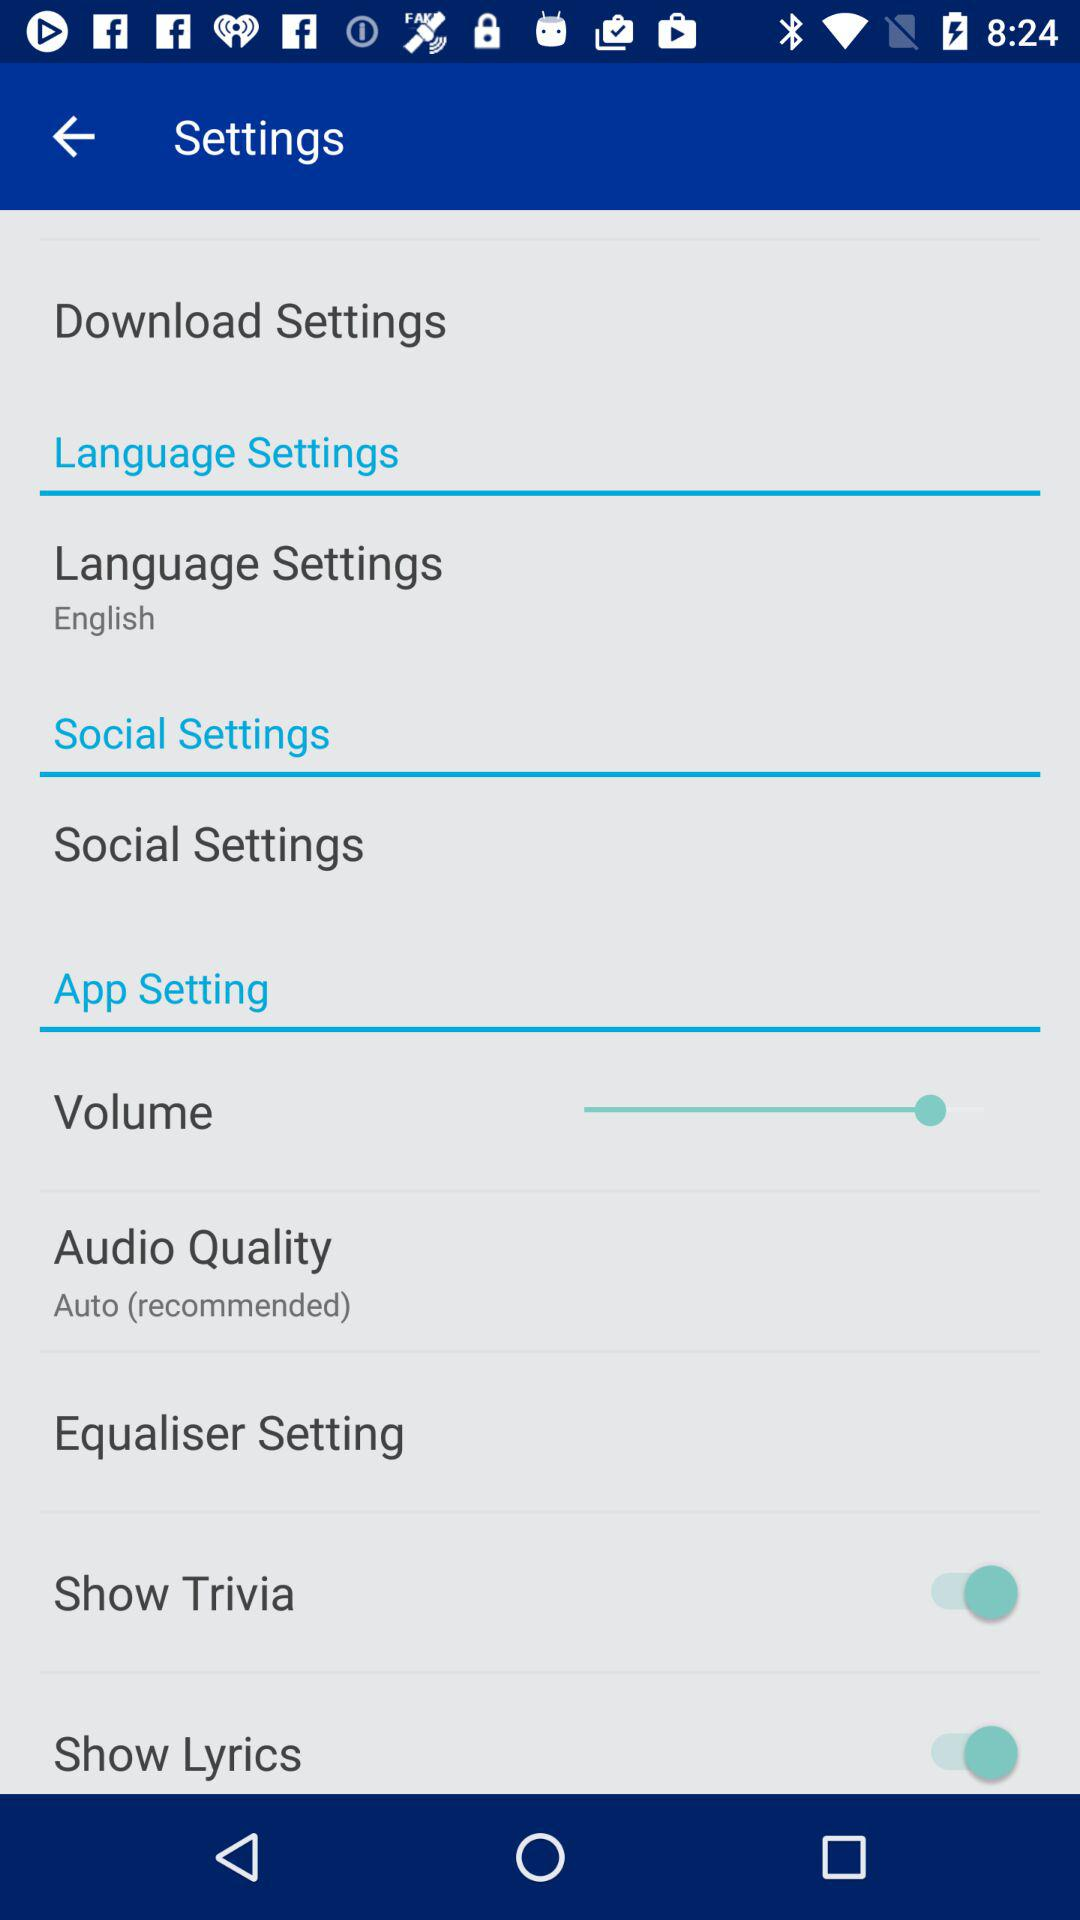What's the selected language setting? The selected language setting is English. 